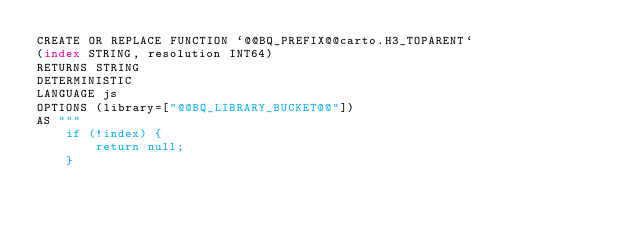Convert code to text. <code><loc_0><loc_0><loc_500><loc_500><_SQL_>CREATE OR REPLACE FUNCTION `@@BQ_PREFIX@@carto.H3_TOPARENT`
(index STRING, resolution INT64)
RETURNS STRING
DETERMINISTIC
LANGUAGE js
OPTIONS (library=["@@BQ_LIBRARY_BUCKET@@"])
AS """
    if (!index) {
        return null;
    }</code> 